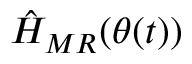<formula> <loc_0><loc_0><loc_500><loc_500>\hat { H } _ { M R } ( \theta ( t ) )</formula> 